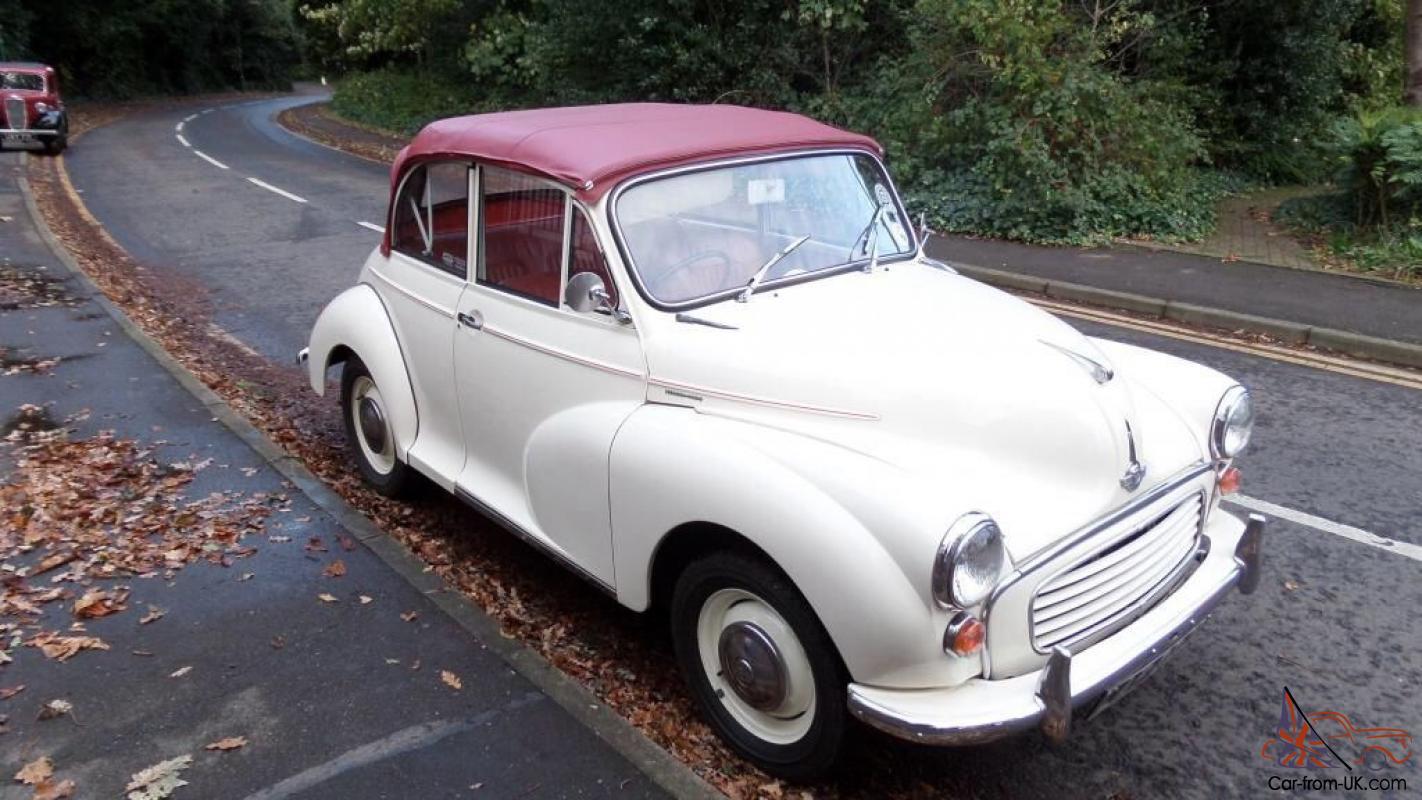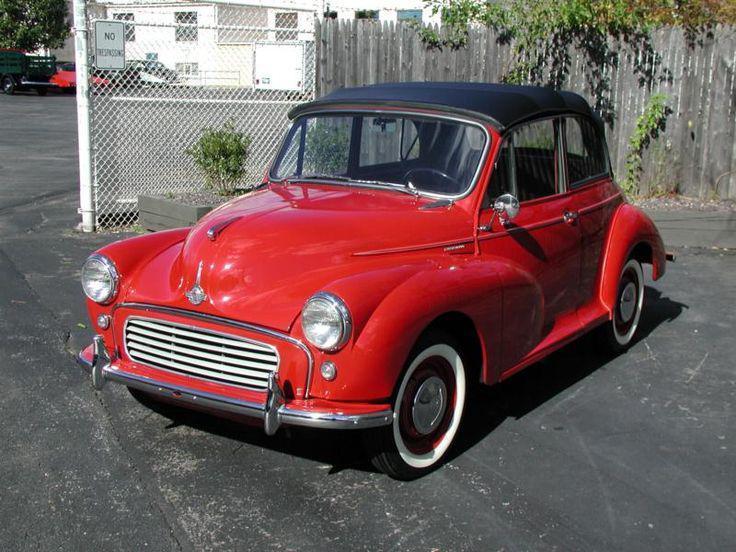The first image is the image on the left, the second image is the image on the right. Examine the images to the left and right. Is the description "There is a blue car and a green car" accurate? Answer yes or no. No. 